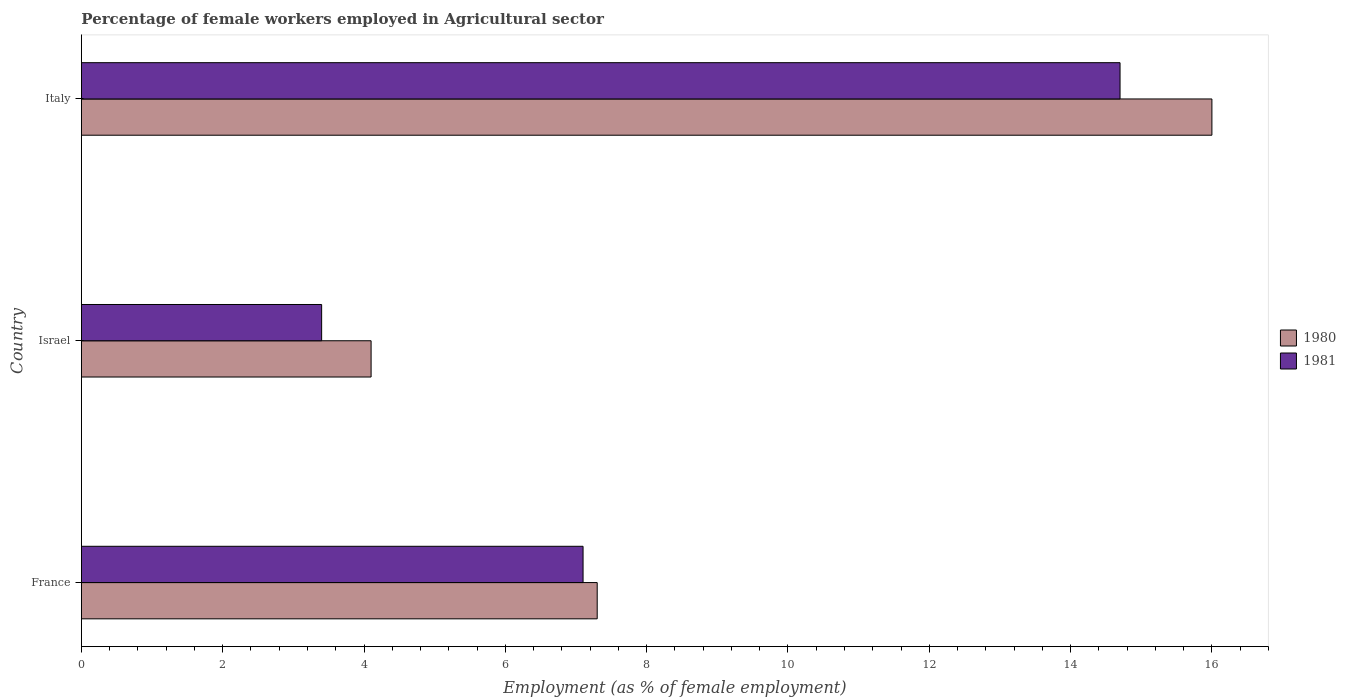How many different coloured bars are there?
Ensure brevity in your answer.  2. How many bars are there on the 3rd tick from the top?
Keep it short and to the point. 2. What is the percentage of females employed in Agricultural sector in 1980 in Israel?
Make the answer very short. 4.1. Across all countries, what is the maximum percentage of females employed in Agricultural sector in 1981?
Provide a short and direct response. 14.7. Across all countries, what is the minimum percentage of females employed in Agricultural sector in 1980?
Provide a short and direct response. 4.1. In which country was the percentage of females employed in Agricultural sector in 1980 minimum?
Provide a succinct answer. Israel. What is the total percentage of females employed in Agricultural sector in 1980 in the graph?
Give a very brief answer. 27.4. What is the difference between the percentage of females employed in Agricultural sector in 1981 in Israel and that in Italy?
Offer a terse response. -11.3. What is the difference between the percentage of females employed in Agricultural sector in 1980 in Italy and the percentage of females employed in Agricultural sector in 1981 in Israel?
Give a very brief answer. 12.6. What is the average percentage of females employed in Agricultural sector in 1980 per country?
Ensure brevity in your answer.  9.13. What is the difference between the percentage of females employed in Agricultural sector in 1981 and percentage of females employed in Agricultural sector in 1980 in France?
Provide a short and direct response. -0.2. What is the ratio of the percentage of females employed in Agricultural sector in 1980 in France to that in Israel?
Keep it short and to the point. 1.78. Is the difference between the percentage of females employed in Agricultural sector in 1981 in France and Israel greater than the difference between the percentage of females employed in Agricultural sector in 1980 in France and Israel?
Your answer should be very brief. Yes. What is the difference between the highest and the second highest percentage of females employed in Agricultural sector in 1981?
Your answer should be very brief. 7.6. What is the difference between the highest and the lowest percentage of females employed in Agricultural sector in 1980?
Keep it short and to the point. 11.9. In how many countries, is the percentage of females employed in Agricultural sector in 1981 greater than the average percentage of females employed in Agricultural sector in 1981 taken over all countries?
Provide a succinct answer. 1. What does the 1st bar from the top in Israel represents?
Offer a very short reply. 1981. What does the 2nd bar from the bottom in Italy represents?
Make the answer very short. 1981. Are all the bars in the graph horizontal?
Your answer should be very brief. Yes. How many countries are there in the graph?
Provide a short and direct response. 3. What is the difference between two consecutive major ticks on the X-axis?
Your response must be concise. 2. Does the graph contain any zero values?
Your response must be concise. No. Does the graph contain grids?
Your answer should be compact. No. Where does the legend appear in the graph?
Give a very brief answer. Center right. How are the legend labels stacked?
Offer a terse response. Vertical. What is the title of the graph?
Your answer should be compact. Percentage of female workers employed in Agricultural sector. What is the label or title of the X-axis?
Ensure brevity in your answer.  Employment (as % of female employment). What is the Employment (as % of female employment) of 1980 in France?
Make the answer very short. 7.3. What is the Employment (as % of female employment) of 1981 in France?
Offer a terse response. 7.1. What is the Employment (as % of female employment) of 1980 in Israel?
Keep it short and to the point. 4.1. What is the Employment (as % of female employment) of 1981 in Israel?
Give a very brief answer. 3.4. What is the Employment (as % of female employment) of 1980 in Italy?
Offer a terse response. 16. What is the Employment (as % of female employment) of 1981 in Italy?
Give a very brief answer. 14.7. Across all countries, what is the maximum Employment (as % of female employment) in 1980?
Ensure brevity in your answer.  16. Across all countries, what is the maximum Employment (as % of female employment) of 1981?
Your answer should be very brief. 14.7. Across all countries, what is the minimum Employment (as % of female employment) of 1980?
Keep it short and to the point. 4.1. Across all countries, what is the minimum Employment (as % of female employment) in 1981?
Keep it short and to the point. 3.4. What is the total Employment (as % of female employment) in 1980 in the graph?
Your answer should be compact. 27.4. What is the total Employment (as % of female employment) in 1981 in the graph?
Provide a short and direct response. 25.2. What is the difference between the Employment (as % of female employment) in 1981 in France and that in Italy?
Provide a succinct answer. -7.6. What is the difference between the Employment (as % of female employment) of 1981 in Israel and that in Italy?
Keep it short and to the point. -11.3. What is the difference between the Employment (as % of female employment) in 1980 in France and the Employment (as % of female employment) in 1981 in Israel?
Your answer should be compact. 3.9. What is the difference between the Employment (as % of female employment) of 1980 in Israel and the Employment (as % of female employment) of 1981 in Italy?
Provide a succinct answer. -10.6. What is the average Employment (as % of female employment) in 1980 per country?
Give a very brief answer. 9.13. What is the difference between the Employment (as % of female employment) of 1980 and Employment (as % of female employment) of 1981 in France?
Give a very brief answer. 0.2. What is the difference between the Employment (as % of female employment) in 1980 and Employment (as % of female employment) in 1981 in Israel?
Provide a short and direct response. 0.7. What is the ratio of the Employment (as % of female employment) in 1980 in France to that in Israel?
Offer a very short reply. 1.78. What is the ratio of the Employment (as % of female employment) of 1981 in France to that in Israel?
Keep it short and to the point. 2.09. What is the ratio of the Employment (as % of female employment) in 1980 in France to that in Italy?
Provide a succinct answer. 0.46. What is the ratio of the Employment (as % of female employment) in 1981 in France to that in Italy?
Ensure brevity in your answer.  0.48. What is the ratio of the Employment (as % of female employment) of 1980 in Israel to that in Italy?
Offer a terse response. 0.26. What is the ratio of the Employment (as % of female employment) of 1981 in Israel to that in Italy?
Offer a terse response. 0.23. What is the difference between the highest and the lowest Employment (as % of female employment) of 1980?
Provide a short and direct response. 11.9. 